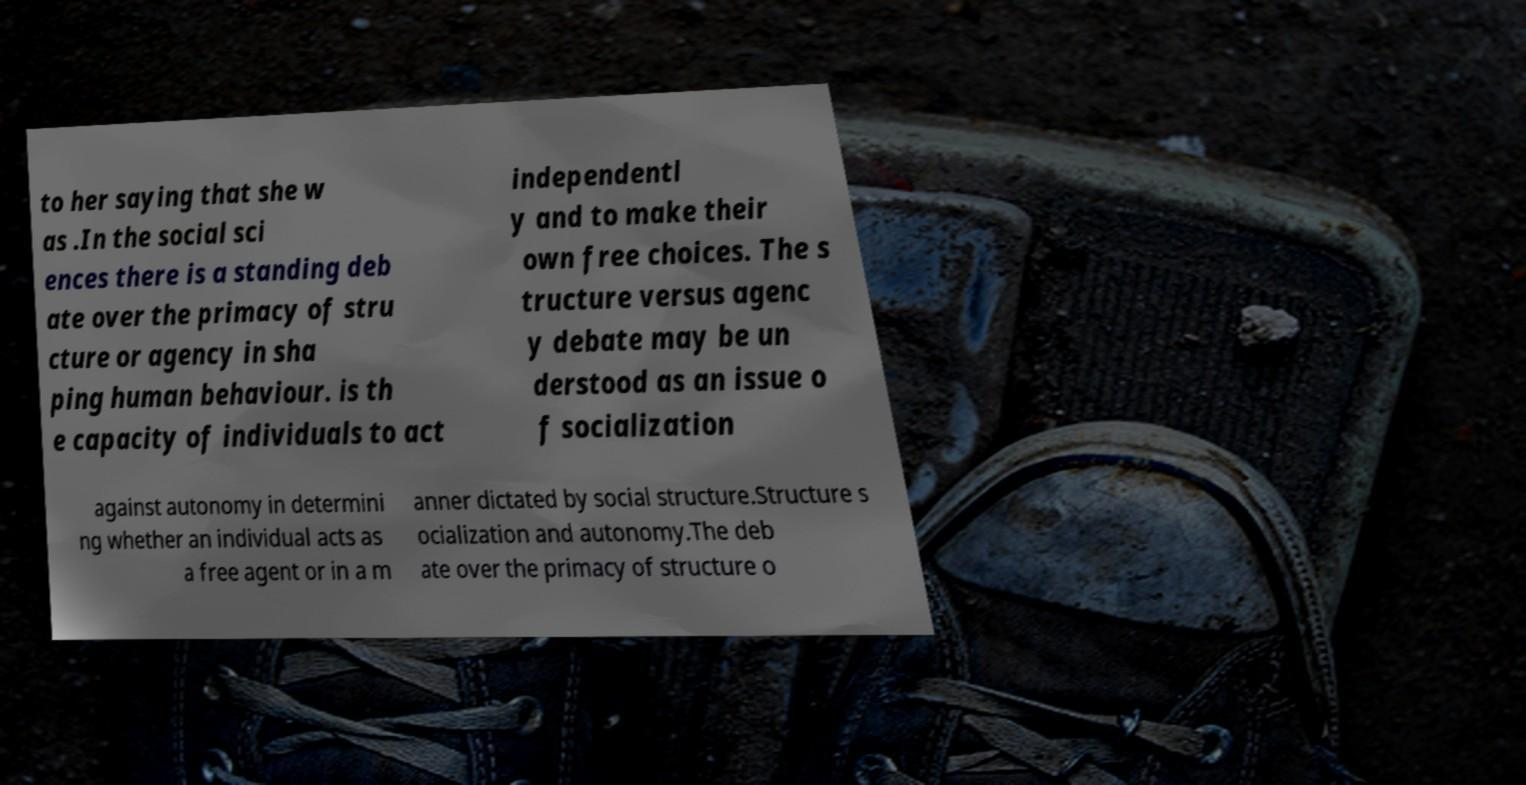Could you assist in decoding the text presented in this image and type it out clearly? to her saying that she w as .In the social sci ences there is a standing deb ate over the primacy of stru cture or agency in sha ping human behaviour. is th e capacity of individuals to act independentl y and to make their own free choices. The s tructure versus agenc y debate may be un derstood as an issue o f socialization against autonomy in determini ng whether an individual acts as a free agent or in a m anner dictated by social structure.Structure s ocialization and autonomy.The deb ate over the primacy of structure o 